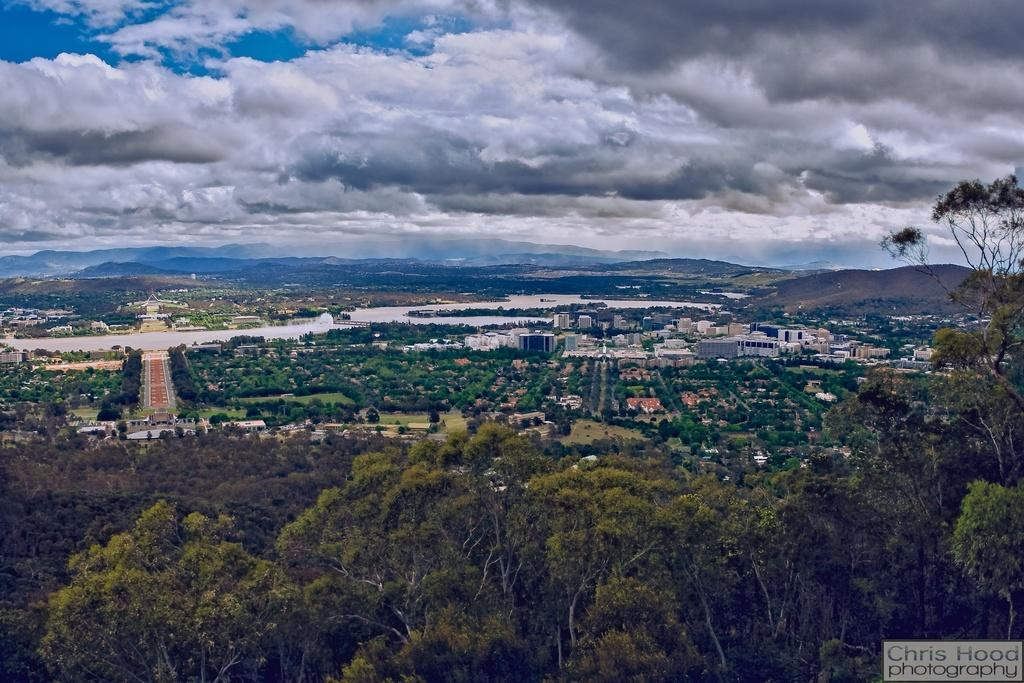What can be seen in the middle of the image? There are buildings, trees, grass, hills, and text in the middle of the image. What type of vegetation is present in the image? There are trees and grass in the image. What geographical feature can be seen in the image? There are hills in the image. What is visible at the top of the image? There are clouds and the sky visible at the top of the image. What caption is written on the grass in the image? There is no caption written on the grass in the image; it is a natural landscape with no text on the grass. Can you describe the laborer working in the image? There are no laborers present in the image; it features a landscape with buildings, trees, grass, hills, and text. 